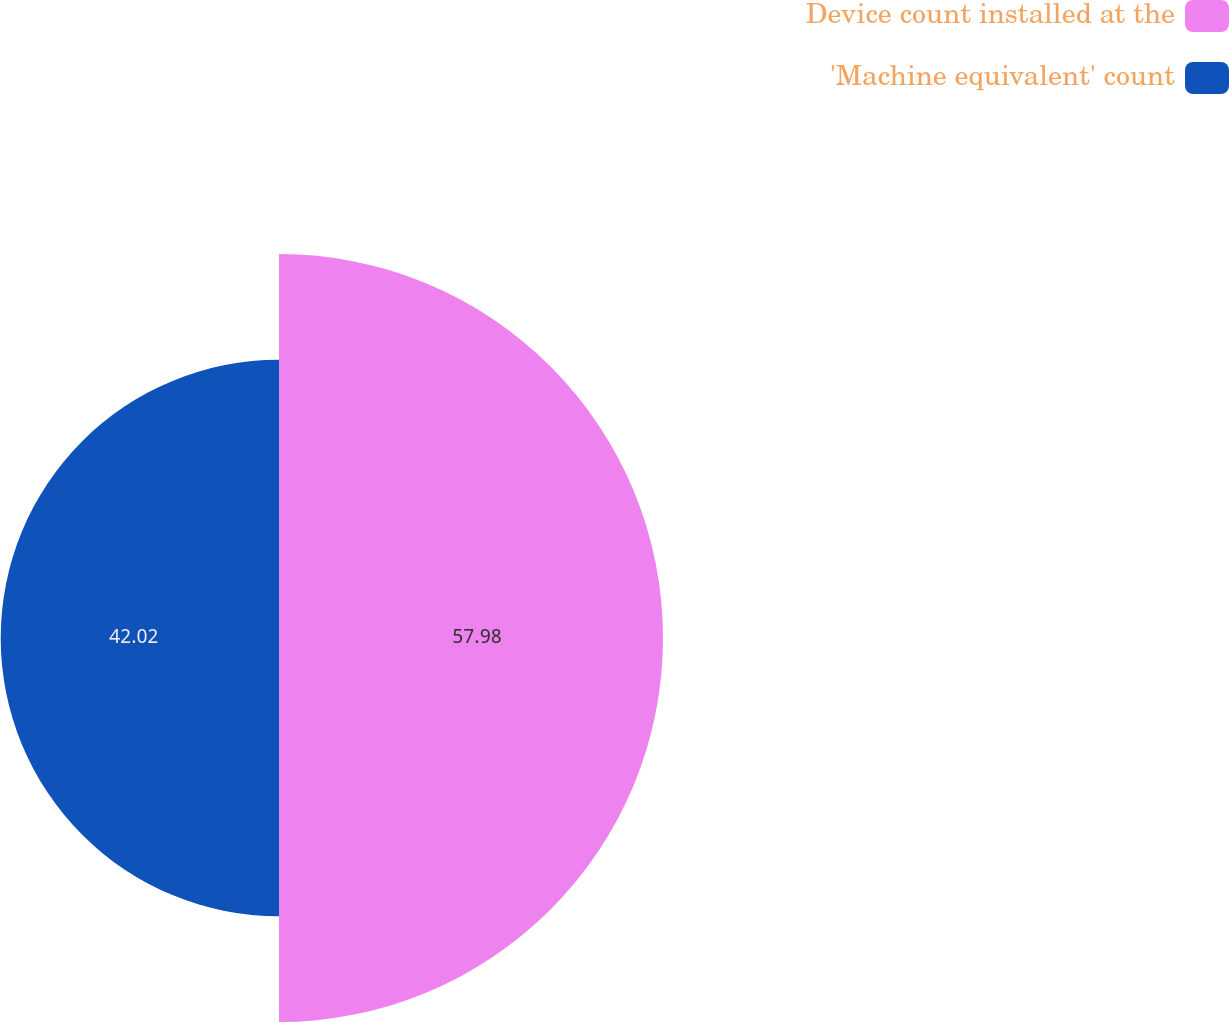Convert chart to OTSL. <chart><loc_0><loc_0><loc_500><loc_500><pie_chart><fcel>Device count installed at the<fcel>'Machine equivalent' count<nl><fcel>57.98%<fcel>42.02%<nl></chart> 